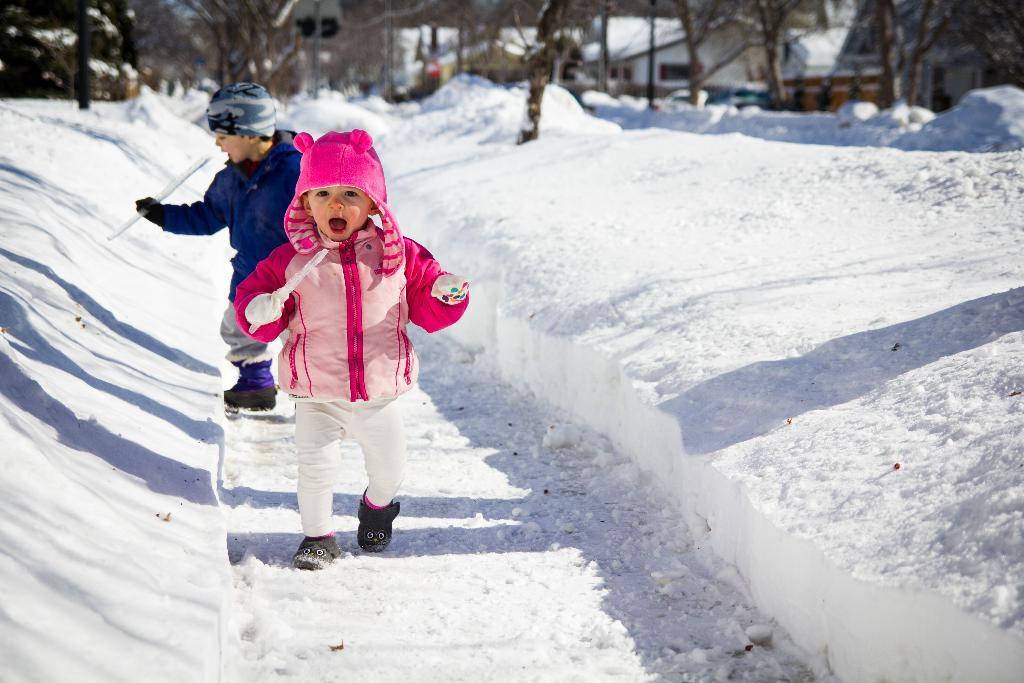Can you describe this image briefly? On the ground there is snow. Also there are two children wearing caps and holding something in the hand. In the background there are trees and buildings. 